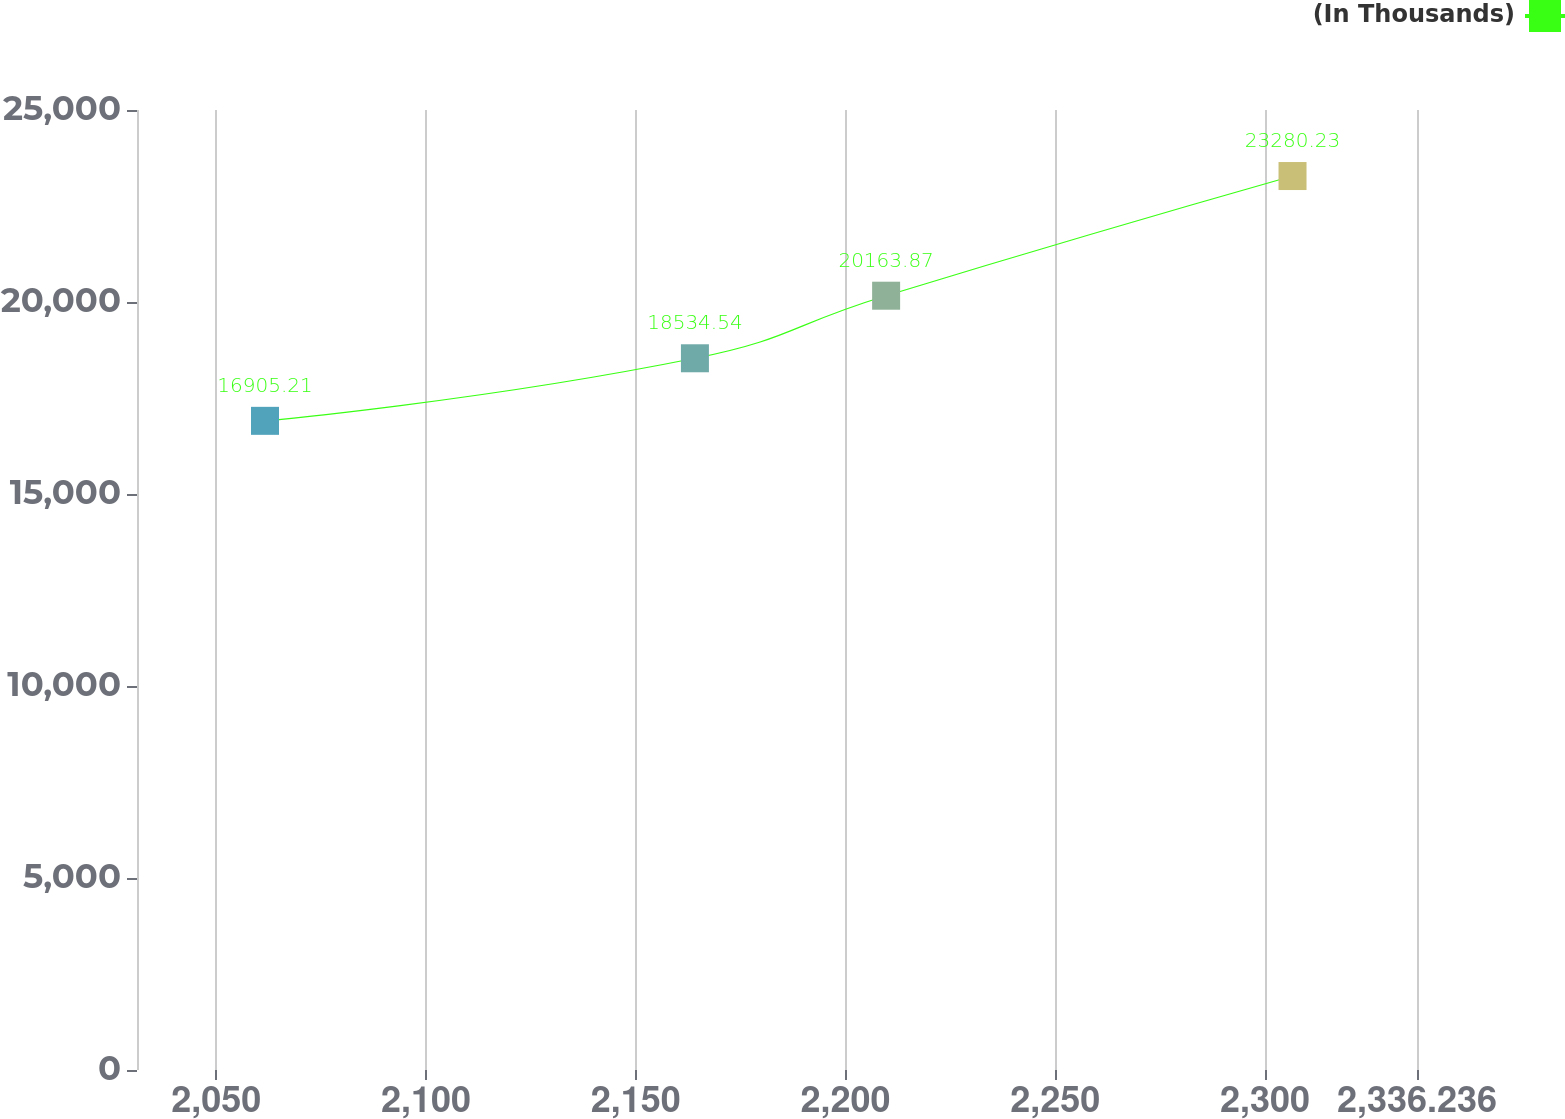Convert chart to OTSL. <chart><loc_0><loc_0><loc_500><loc_500><line_chart><ecel><fcel>(In Thousands)<nl><fcel>2061.61<fcel>16905.2<nl><fcel>2164.1<fcel>18534.5<nl><fcel>2209.68<fcel>20163.9<nl><fcel>2306.56<fcel>23280.2<nl><fcel>2366.75<fcel>33198.6<nl></chart> 